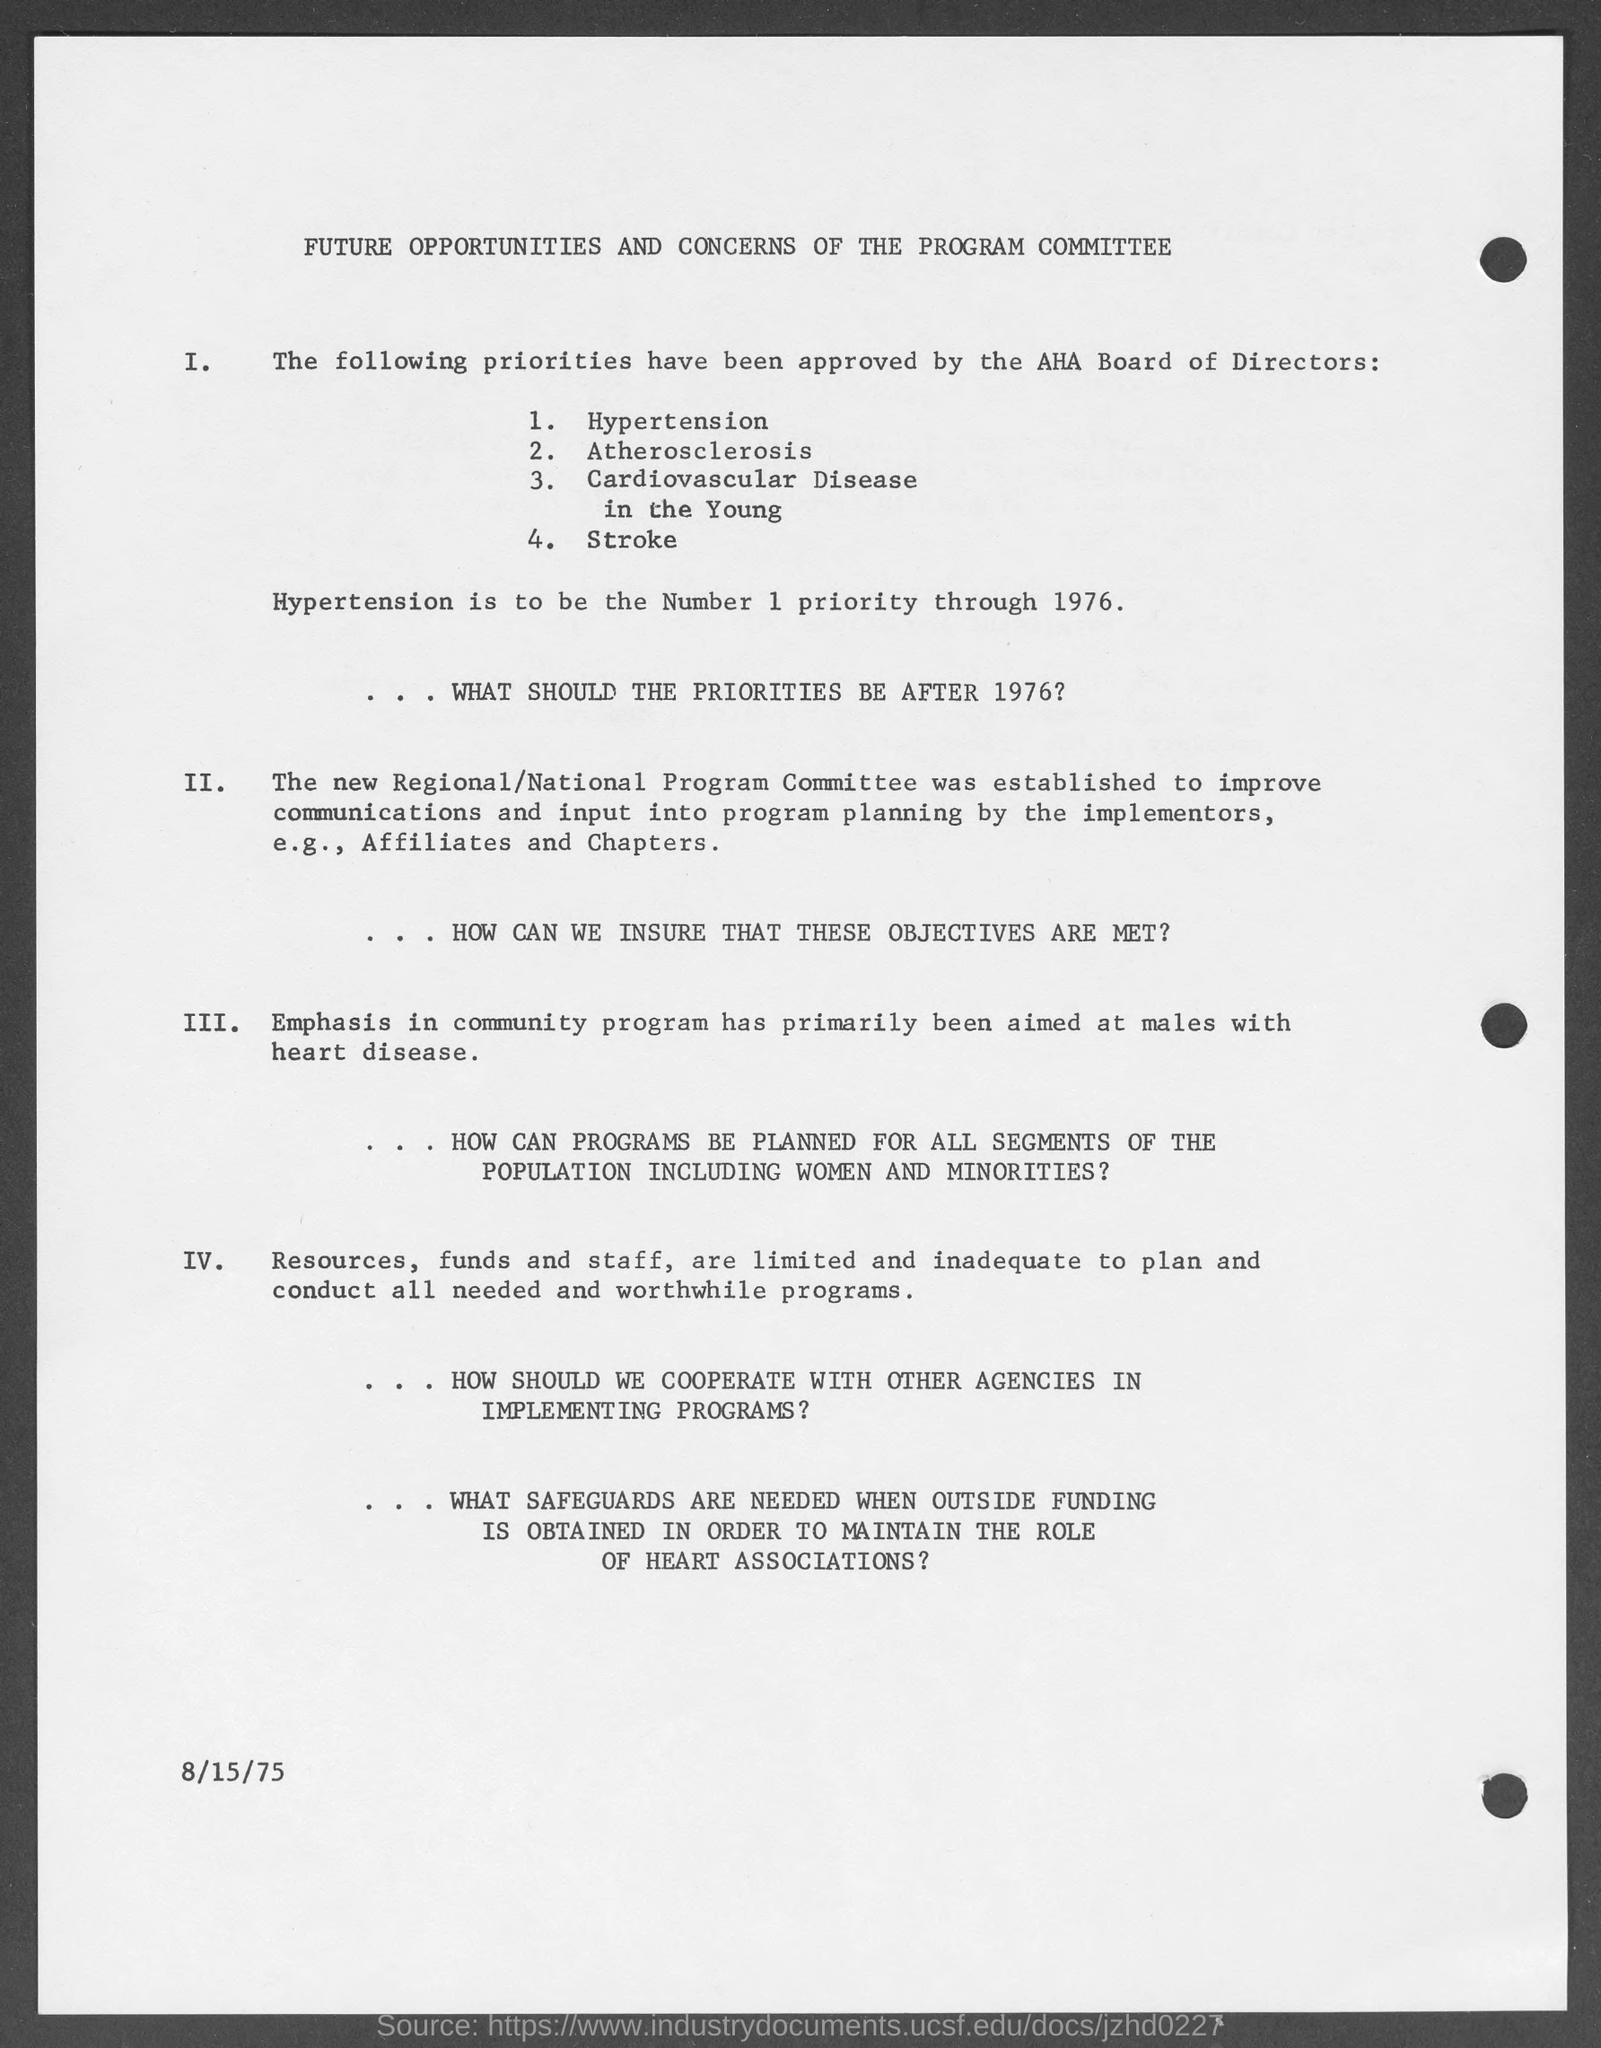What is the date at bottom of the page?
Your response must be concise. 8/15/75. What must be number 1 priority through 1976?
Provide a short and direct response. Hypertension. What is number 4 priority as approved by the aha board of directors?
Keep it short and to the point. Stroke. What is number 2 priority as approved by the aha board of directors?
Your answer should be compact. Atherosclerosis. What is number 3 priority as approved by the aha board of directors?
Provide a short and direct response. Cardiovascular disease in the Young. 